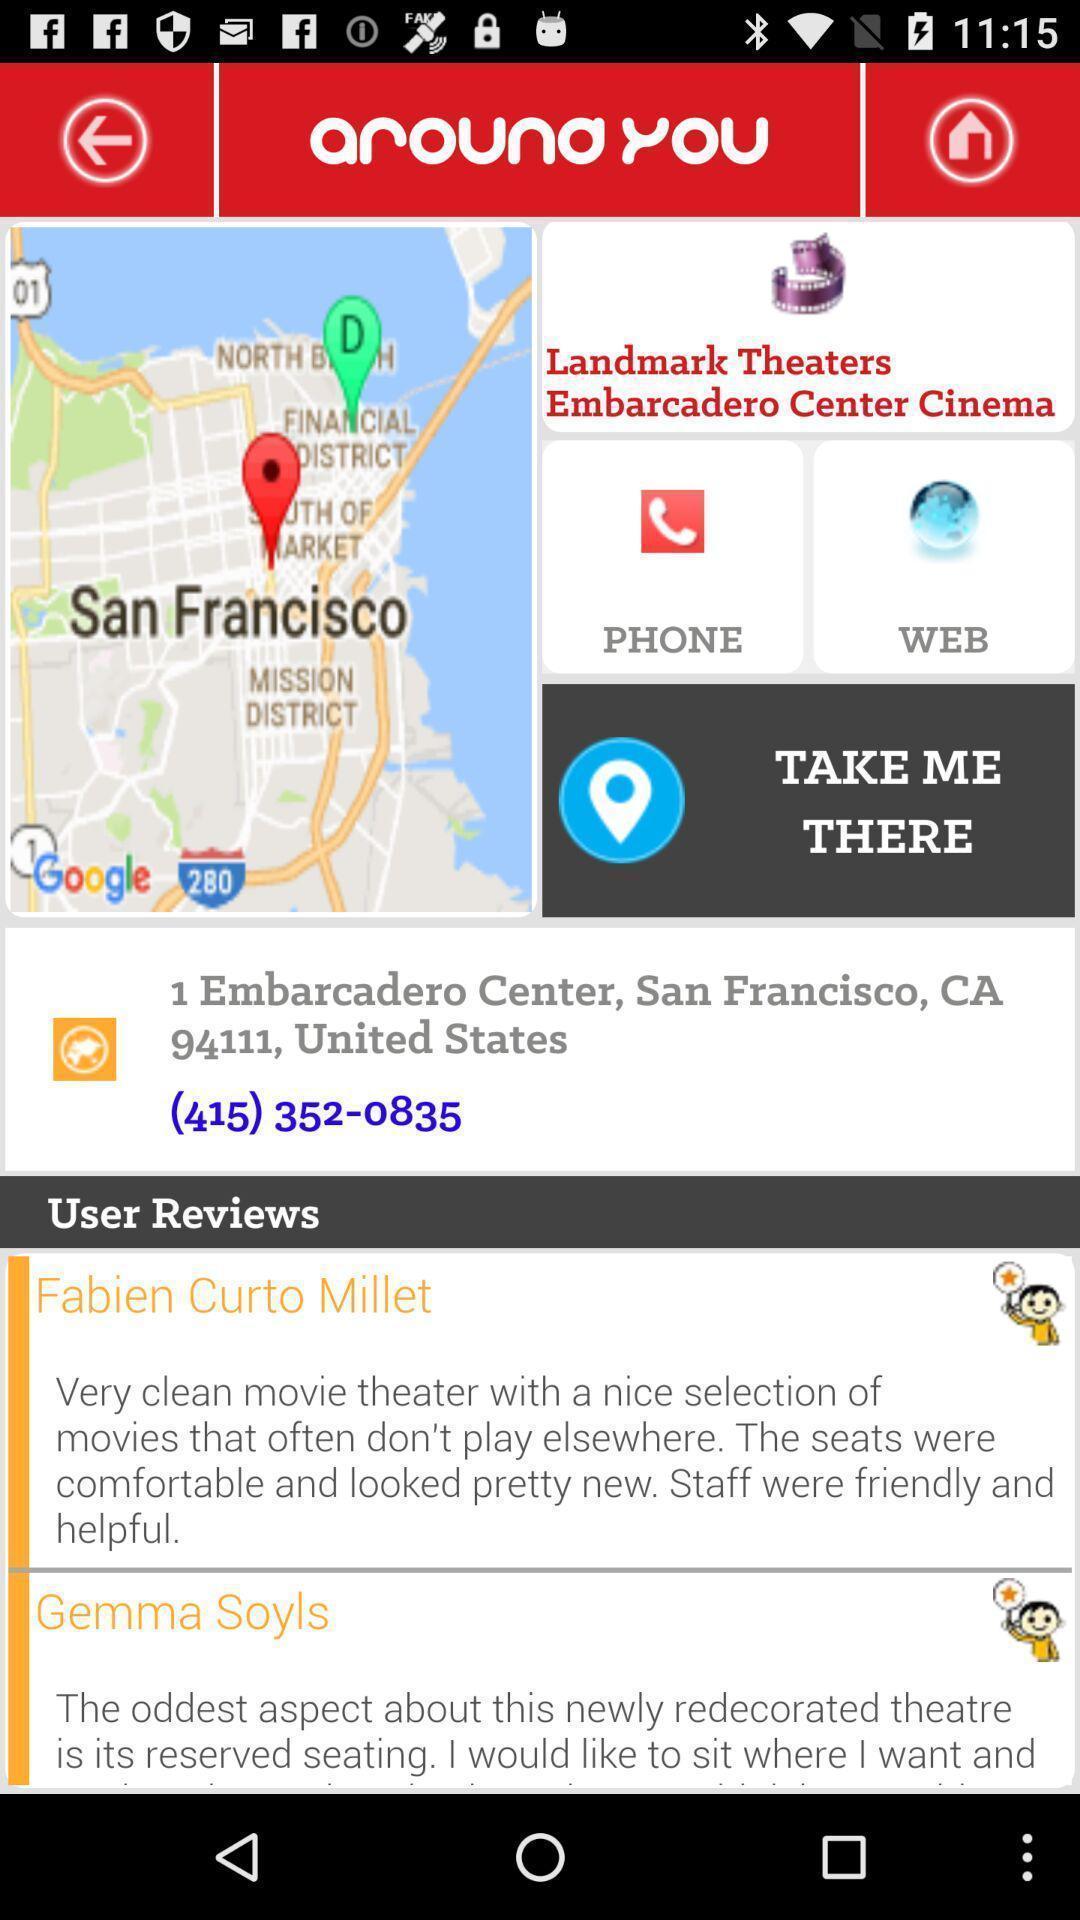Describe the key features of this screenshot. Page that displaying gps location. 